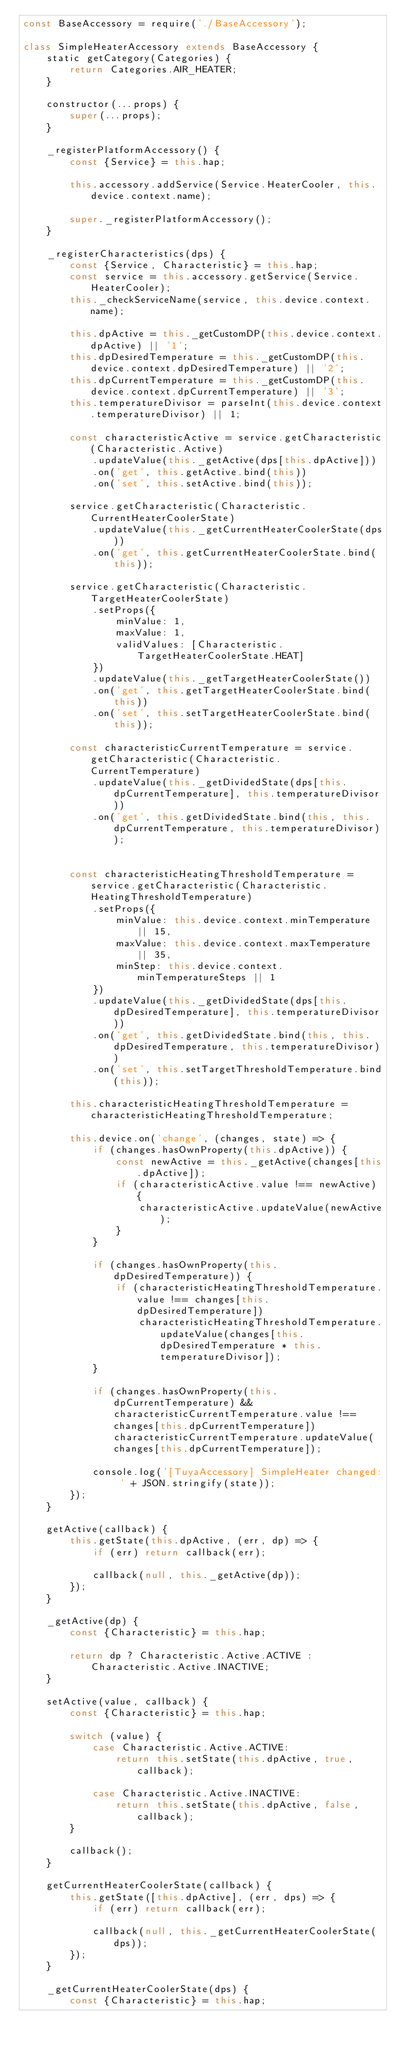<code> <loc_0><loc_0><loc_500><loc_500><_JavaScript_>const BaseAccessory = require('./BaseAccessory');

class SimpleHeaterAccessory extends BaseAccessory {
    static getCategory(Categories) {
        return Categories.AIR_HEATER;
    }

    constructor(...props) {
        super(...props);
    }

    _registerPlatformAccessory() {
        const {Service} = this.hap;

        this.accessory.addService(Service.HeaterCooler, this.device.context.name);

        super._registerPlatformAccessory();
    }

    _registerCharacteristics(dps) {
        const {Service, Characteristic} = this.hap;
        const service = this.accessory.getService(Service.HeaterCooler);
        this._checkServiceName(service, this.device.context.name);

        this.dpActive = this._getCustomDP(this.device.context.dpActive) || '1';
        this.dpDesiredTemperature = this._getCustomDP(this.device.context.dpDesiredTemperature) || '2';
        this.dpCurrentTemperature = this._getCustomDP(this.device.context.dpCurrentTemperature) || '3';
        this.temperatureDivisor = parseInt(this.device.context.temperatureDivisor) || 1;

        const characteristicActive = service.getCharacteristic(Characteristic.Active)
            .updateValue(this._getActive(dps[this.dpActive]))
            .on('get', this.getActive.bind(this))
            .on('set', this.setActive.bind(this));

        service.getCharacteristic(Characteristic.CurrentHeaterCoolerState)
            .updateValue(this._getCurrentHeaterCoolerState(dps))
            .on('get', this.getCurrentHeaterCoolerState.bind(this));

        service.getCharacteristic(Characteristic.TargetHeaterCoolerState)
            .setProps({
                minValue: 1,
                maxValue: 1,
                validValues: [Characteristic.TargetHeaterCoolerState.HEAT]
            })
            .updateValue(this._getTargetHeaterCoolerState())
            .on('get', this.getTargetHeaterCoolerState.bind(this))
            .on('set', this.setTargetHeaterCoolerState.bind(this));

        const characteristicCurrentTemperature = service.getCharacteristic(Characteristic.CurrentTemperature)
            .updateValue(this._getDividedState(dps[this.dpCurrentTemperature], this.temperatureDivisor))
            .on('get', this.getDividedState.bind(this, this.dpCurrentTemperature, this.temperatureDivisor));


        const characteristicHeatingThresholdTemperature = service.getCharacteristic(Characteristic.HeatingThresholdTemperature)
            .setProps({
                minValue: this.device.context.minTemperature || 15,
                maxValue: this.device.context.maxTemperature || 35,
                minStep: this.device.context.minTemperatureSteps || 1
            })
            .updateValue(this._getDividedState(dps[this.dpDesiredTemperature], this.temperatureDivisor))
            .on('get', this.getDividedState.bind(this, this.dpDesiredTemperature, this.temperatureDivisor))
            .on('set', this.setTargetThresholdTemperature.bind(this));

        this.characteristicHeatingThresholdTemperature = characteristicHeatingThresholdTemperature;

        this.device.on('change', (changes, state) => {
            if (changes.hasOwnProperty(this.dpActive)) {
                const newActive = this._getActive(changes[this.dpActive]);
                if (characteristicActive.value !== newActive) {
                    characteristicActive.updateValue(newActive);
                }
            }

            if (changes.hasOwnProperty(this.dpDesiredTemperature)) {
                if (characteristicHeatingThresholdTemperature.value !== changes[this.dpDesiredTemperature])
                    characteristicHeatingThresholdTemperature.updateValue(changes[this.dpDesiredTemperature * this.temperatureDivisor]);
            }

            if (changes.hasOwnProperty(this.dpCurrentTemperature) && characteristicCurrentTemperature.value !== changes[this.dpCurrentTemperature]) characteristicCurrentTemperature.updateValue(changes[this.dpCurrentTemperature]);

            console.log('[TuyaAccessory] SimpleHeater changed: ' + JSON.stringify(state));
        });
    }

    getActive(callback) {
        this.getState(this.dpActive, (err, dp) => {
            if (err) return callback(err);

            callback(null, this._getActive(dp));
        });
    }

    _getActive(dp) {
        const {Characteristic} = this.hap;

        return dp ? Characteristic.Active.ACTIVE : Characteristic.Active.INACTIVE;
    }

    setActive(value, callback) {
        const {Characteristic} = this.hap;

        switch (value) {
            case Characteristic.Active.ACTIVE:
                return this.setState(this.dpActive, true, callback);

            case Characteristic.Active.INACTIVE:
                return this.setState(this.dpActive, false, callback);
        }

        callback();
    }

    getCurrentHeaterCoolerState(callback) {
        this.getState([this.dpActive], (err, dps) => {
            if (err) return callback(err);

            callback(null, this._getCurrentHeaterCoolerState(dps));
        });
    }

    _getCurrentHeaterCoolerState(dps) {
        const {Characteristic} = this.hap;</code> 